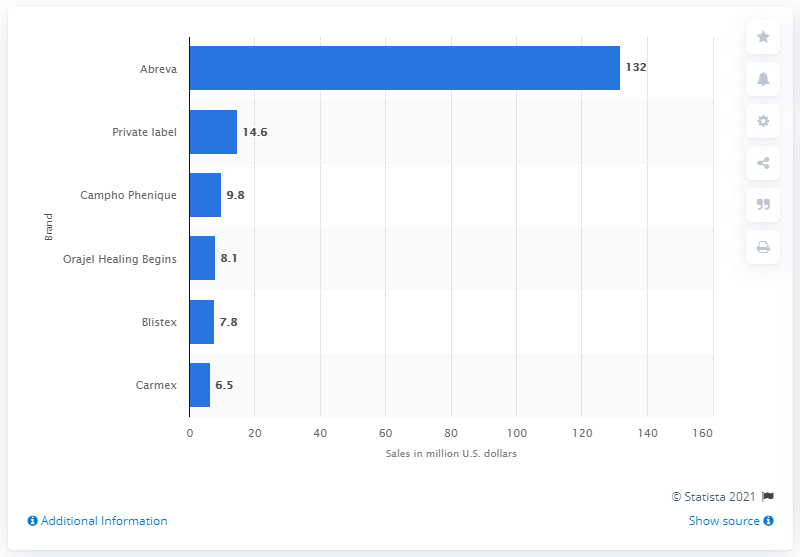Mention a couple of crucial points in this snapshot. In the year 2014, Abreva was the leading brand of cold sore treatment in the United States. 